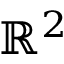<formula> <loc_0><loc_0><loc_500><loc_500>\mathbb { R } ^ { 2 }</formula> 